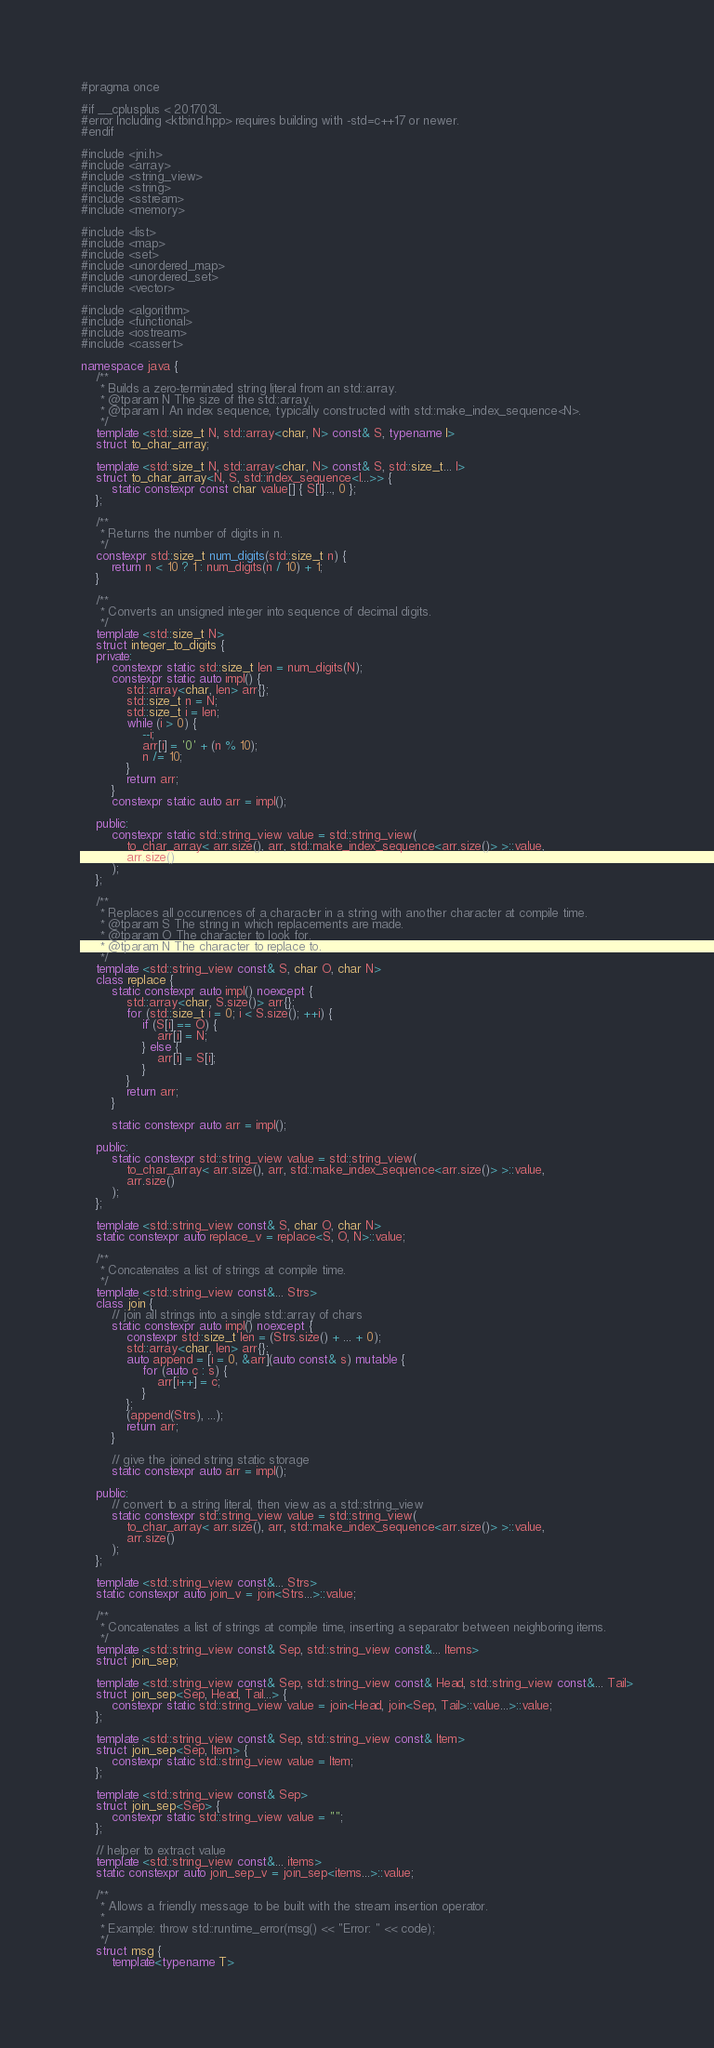<code> <loc_0><loc_0><loc_500><loc_500><_C++_>#pragma once

#if __cplusplus < 201703L
#error Including <ktbind.hpp> requires building with -std=c++17 or newer.
#endif

#include <jni.h>
#include <array>
#include <string_view>
#include <string>
#include <sstream>
#include <memory>

#include <list>
#include <map>
#include <set>
#include <unordered_map>
#include <unordered_set>
#include <vector>

#include <algorithm>
#include <functional>
#include <iostream>
#include <cassert>

namespace java {
    /** 
     * Builds a zero-terminated string literal from an std::array.
     * @tparam N The size of the std::array.
     * @tparam I An index sequence, typically constructed with std::make_index_sequence<N>.
     */
    template <std::size_t N, std::array<char, N> const& S, typename I>
    struct to_char_array;

    template <std::size_t N, std::array<char, N> const& S, std::size_t... I>
    struct to_char_array<N, S, std::index_sequence<I...>> {
        static constexpr const char value[] { S[I]..., 0 };
    };

    /**
     * Returns the number of digits in n.
     */ 
    constexpr std::size_t num_digits(std::size_t n) {
        return n < 10 ? 1 : num_digits(n / 10) + 1;
    }

    /**
     * Converts an unsigned integer into sequence of decimal digits.
     */
    template <std::size_t N>
    struct integer_to_digits {
    private:
        constexpr static std::size_t len = num_digits(N);
        constexpr static auto impl() {
            std::array<char, len> arr{};
            std::size_t n = N;
            std::size_t i = len;
            while (i > 0) {
                --i;
                arr[i] = '0' + (n % 10);
                n /= 10;
            }
            return arr;
        }
        constexpr static auto arr = impl();

    public:
        constexpr static std::string_view value = std::string_view(
            to_char_array< arr.size(), arr, std::make_index_sequence<arr.size()> >::value,
            arr.size()
        );
    };

    /**
     * Replaces all occurrences of a character in a string with another character at compile time.
     * @tparam S The string in which replacements are made.
     * @tparam O The character to look for.
     * @tparam N The character to replace to.
     */
    template <std::string_view const& S, char O, char N>
    class replace {
        static constexpr auto impl() noexcept {
            std::array<char, S.size()> arr{};
            for (std::size_t i = 0; i < S.size(); ++i) {
                if (S[i] == O) {
                    arr[i] = N;
                } else {
                    arr[i] = S[i];
                }
            }
            return arr;
        }

        static constexpr auto arr = impl();

    public:
        static constexpr std::string_view value = std::string_view(
            to_char_array< arr.size(), arr, std::make_index_sequence<arr.size()> >::value,
            arr.size()
        );
    };

    template <std::string_view const& S, char O, char N>
    static constexpr auto replace_v = replace<S, O, N>::value;

    /**
     * Concatenates a list of strings at compile time.
     */
    template <std::string_view const&... Strs>
    class join {
        // join all strings into a single std::array of chars
        static constexpr auto impl() noexcept {
            constexpr std::size_t len = (Strs.size() + ... + 0);
            std::array<char, len> arr{};
            auto append = [i = 0, &arr](auto const& s) mutable {
                for (auto c : s) {
                    arr[i++] = c;
                }
            };
            (append(Strs), ...);
            return arr;
        }

        // give the joined string static storage
        static constexpr auto arr = impl();

    public:
        // convert to a string literal, then view as a std::string_view
        static constexpr std::string_view value = std::string_view(
            to_char_array< arr.size(), arr, std::make_index_sequence<arr.size()> >::value,
            arr.size()
        );
    };

    template <std::string_view const&... Strs>
    static constexpr auto join_v = join<Strs...>::value;

    /**
     * Concatenates a list of strings at compile time, inserting a separator between neighboring items.
     */
    template <std::string_view const& Sep, std::string_view const&... Items>
    struct join_sep;
    
    template <std::string_view const& Sep, std::string_view const& Head, std::string_view const&... Tail>
    struct join_sep<Sep, Head, Tail...> {
        constexpr static std::string_view value = join<Head, join<Sep, Tail>::value...>::value;
    };

    template <std::string_view const& Sep, std::string_view const& Item>
    struct join_sep<Sep, Item> {
        constexpr static std::string_view value = Item;
    };

    template <std::string_view const& Sep>
    struct join_sep<Sep> {
        constexpr static std::string_view value = "";
    };

    // helper to extract value
    template <std::string_view const&... items>
    static constexpr auto join_sep_v = join_sep<items...>::value;

    /**
     * Allows a friendly message to be built with the stream insertion operator.
     * 
     * Example: throw std::runtime_error(msg() << "Error: " << code);
     */
    struct msg {
        template<typename T></code> 